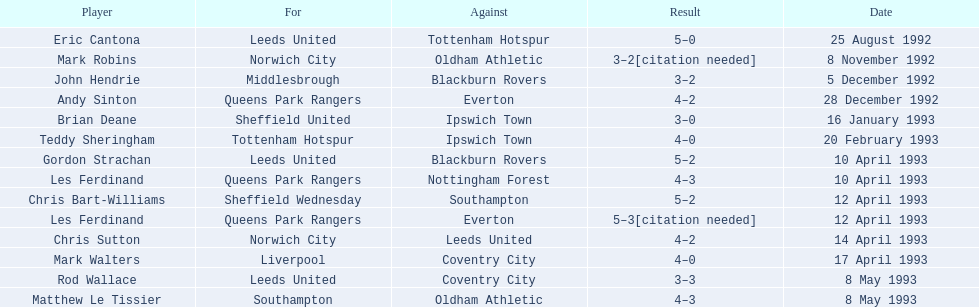Who does john hendrie play for? Middlesbrough. 